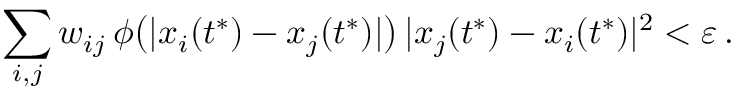<formula> <loc_0><loc_0><loc_500><loc_500>\sum _ { i , j } w _ { i j } \, \phi \left ( | x _ { i } ( t ^ { * } ) - x _ { j } ( t ^ { * } ) | \right ) \, | x _ { j } ( t ^ { * } ) - x _ { i } ( t ^ { * } ) | ^ { 2 } < \varepsilon \, .</formula> 